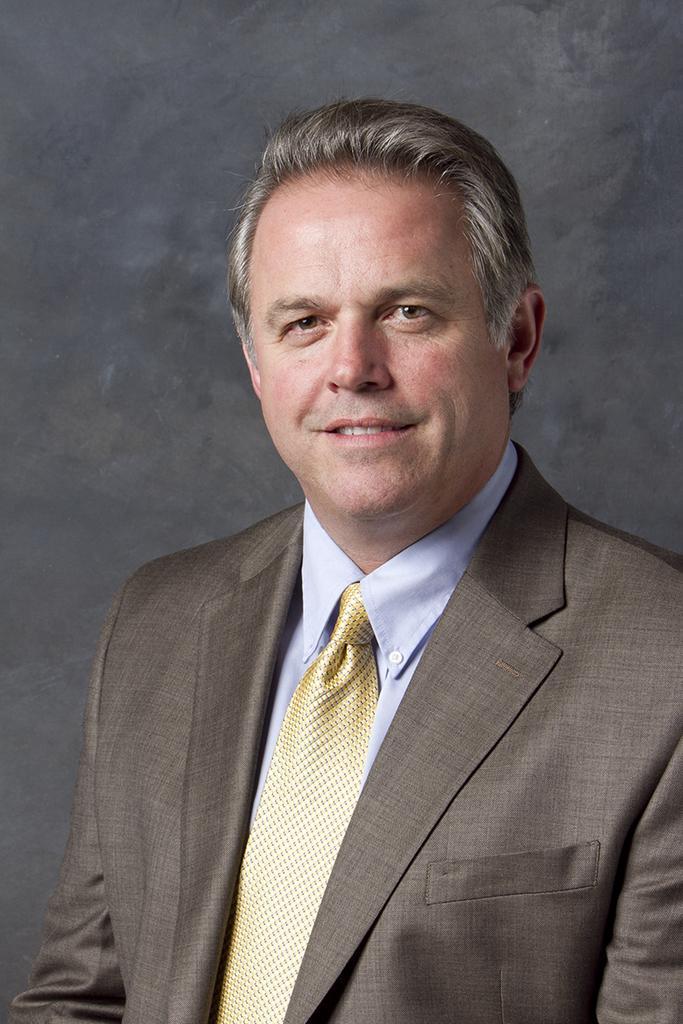Could you give a brief overview of what you see in this image? In this image there is a man wearing brown suit, golden tie and blue shirt. He is smiling. 